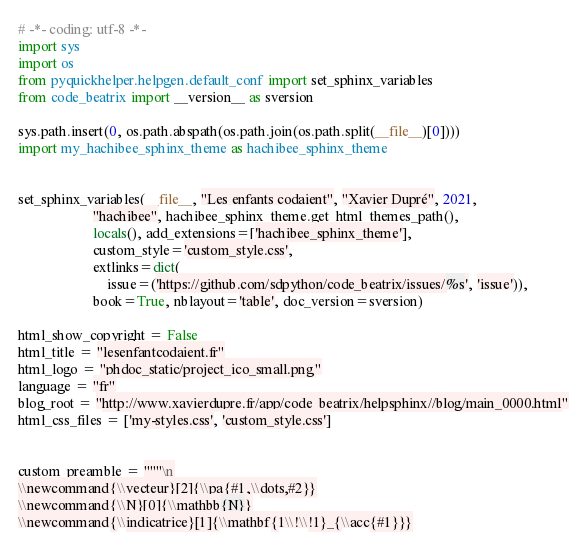<code> <loc_0><loc_0><loc_500><loc_500><_Python_># -*- coding: utf-8 -*-
import sys
import os
from pyquickhelper.helpgen.default_conf import set_sphinx_variables
from code_beatrix import __version__ as sversion

sys.path.insert(0, os.path.abspath(os.path.join(os.path.split(__file__)[0])))
import my_hachibee_sphinx_theme as hachibee_sphinx_theme


set_sphinx_variables(__file__, "Les enfants codaient", "Xavier Dupré", 2021,
                     "hachibee", hachibee_sphinx_theme.get_html_themes_path(),
                     locals(), add_extensions=['hachibee_sphinx_theme'],
                     custom_style='custom_style.css',
                     extlinks=dict(
                         issue=('https://github.com/sdpython/code_beatrix/issues/%s', 'issue')),
                     book=True, nblayout='table', doc_version=sversion)

html_show_copyright = False
html_title = "lesenfantcodaient.fr"
html_logo = "phdoc_static/project_ico_small.png"
language = "fr"
blog_root = "http://www.xavierdupre.fr/app/code_beatrix/helpsphinx//blog/main_0000.html"
html_css_files = ['my-styles.css', 'custom_style.css']


custom_preamble = """\n
\\newcommand{\\vecteur}[2]{\\pa{#1,\\dots,#2}}
\\newcommand{\\N}[0]{\\mathbb{N}}
\\newcommand{\\indicatrice}[1]{\\mathbf{1\\!\\!1}_{\\acc{#1}}}</code> 